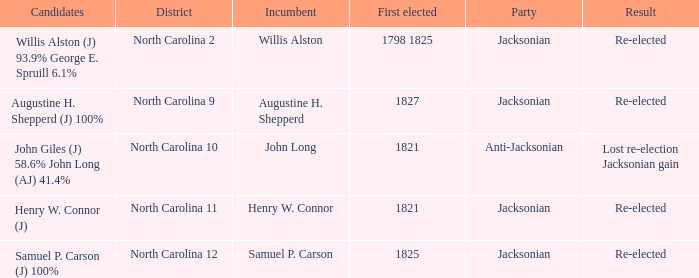Name the district for anti-jacksonian North Carolina 10. 